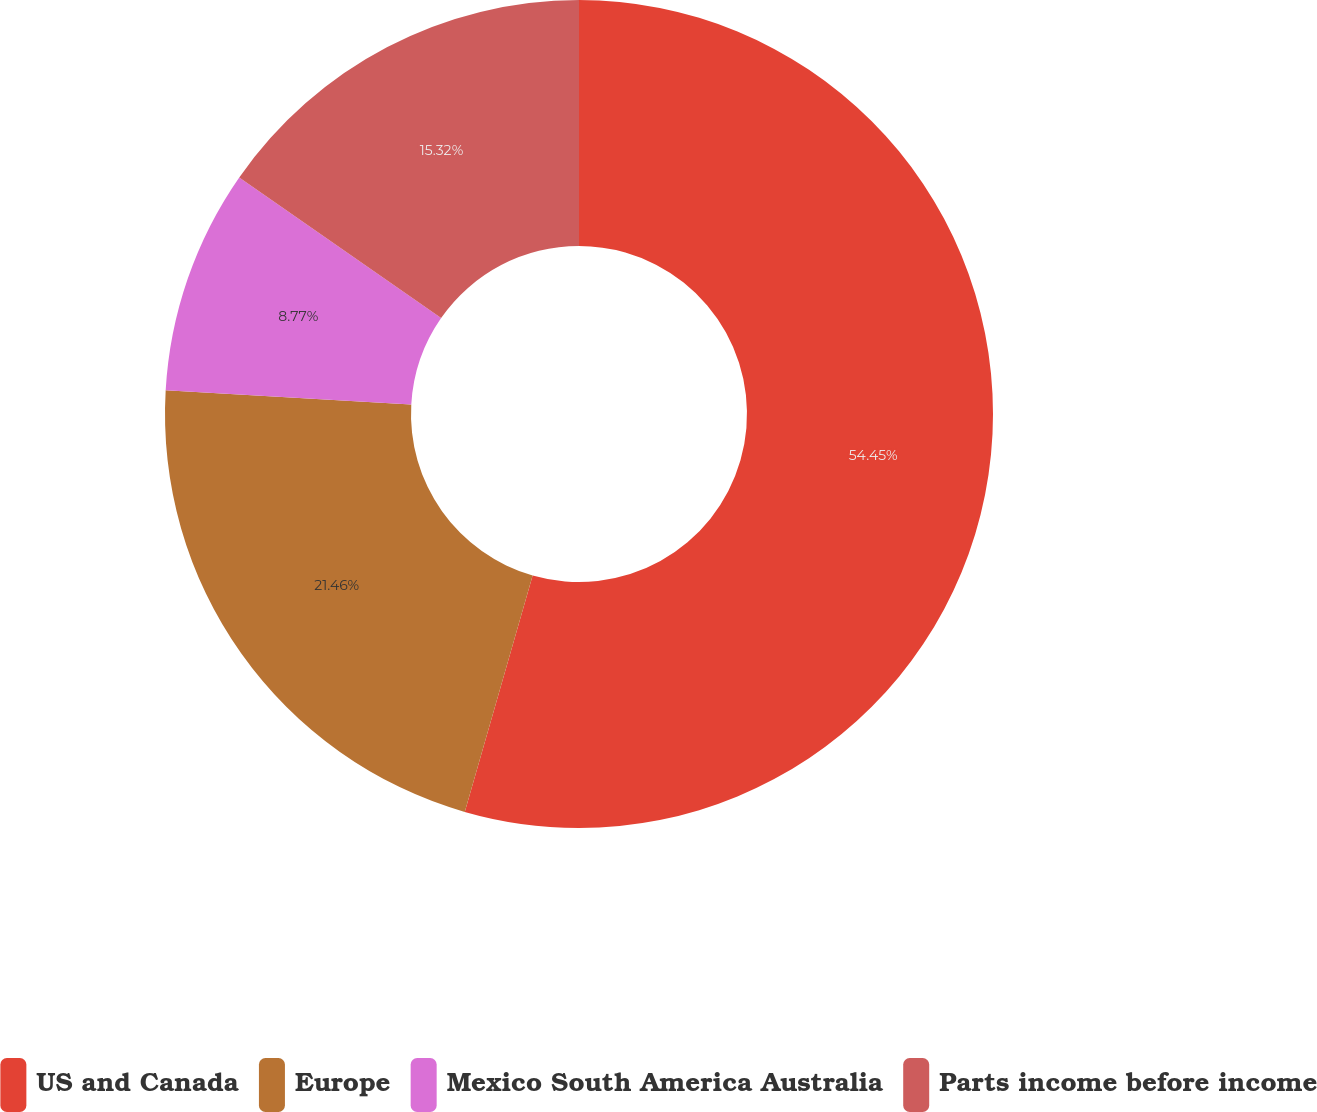<chart> <loc_0><loc_0><loc_500><loc_500><pie_chart><fcel>US and Canada<fcel>Europe<fcel>Mexico South America Australia<fcel>Parts income before income<nl><fcel>54.45%<fcel>21.46%<fcel>8.77%<fcel>15.32%<nl></chart> 